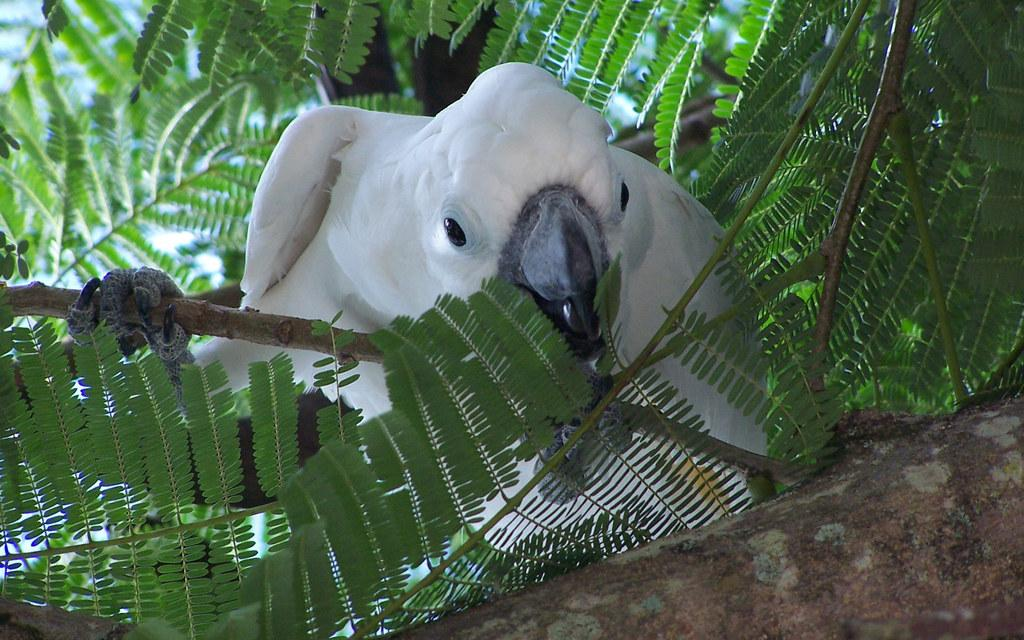What type of animal can be seen in the image? There is a bird in the image. What can be seen in the background of the image? There are leaves visible in the background of the image. What type of brick is the bird using to embark on its journey in the image? There is no brick or journey present in the image; it features a bird and leaves in the background. 